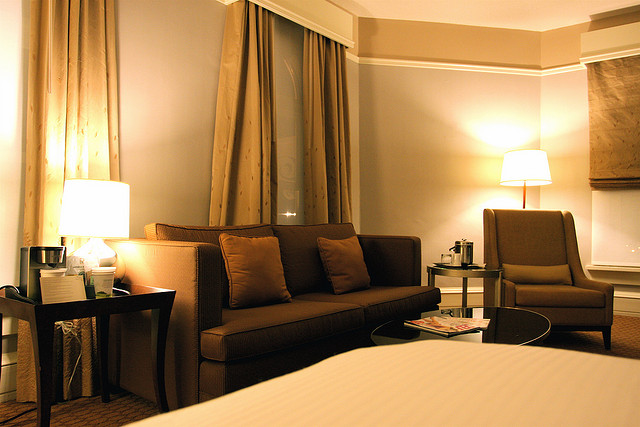<image>What wattage light bulbs are in the lamps? It's not clear what wattage light bulbs are in the lamps. What wattage light bulbs are in the lamps? I don't know what wattage light bulbs are in the lamps. It can be 35, 100, 15, 60 or 200. 